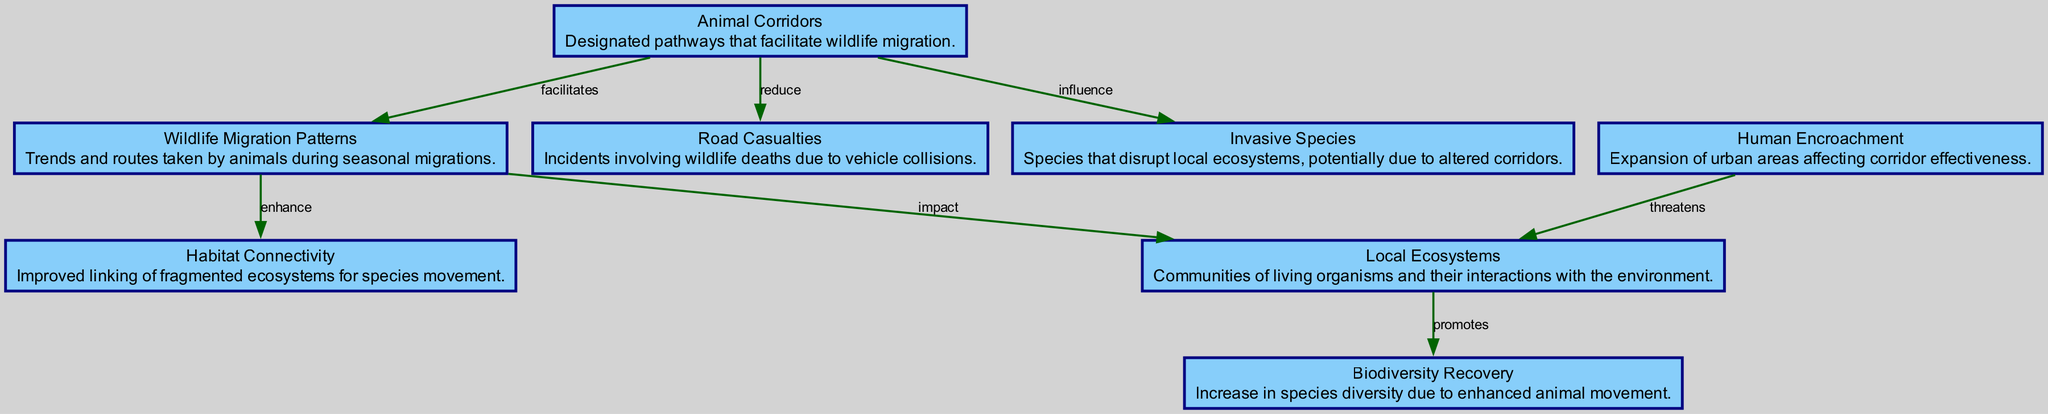What is the total number of nodes in this diagram? The diagram includes each individual entity as a node, which are: Animal Corridors, Wildlife Migration Patterns, Local Ecosystems, Biodiversity Recovery, Road Casualties, Habitat Connectivity, Invasive Species, and Human Encroachment. Counting them gives a total of 8 nodes.
Answer: 8 How many edges are present in the diagram? Each directed connection between nodes is counted as an edge. The edges are as follows: Animal Corridors to Wildlife Migration Patterns, Wildlife Migration Patterns to Local Ecosystems, Local Ecosystems to Biodiversity Recovery, Animal Corridors to Road Casualties, Wildlife Migration Patterns to Habitat Connectivity, Animal Corridors to Invasive Species, and Human Encroachment to Local Ecosystems. Counting these connections yields 7 edges.
Answer: 7 What is the label of the edge connecting Animal Corridors and Wildlife Migration Patterns? The edge that connects Animal Corridors to Wildlife Migration Patterns is labeled "facilitates." This label indicates the nature of the relationship between these two entities.
Answer: facilitates Which node promotes Biodiversity Recovery? The node that promotes Biodiversity Recovery is Local Ecosystems. This indicates that the health or attributes of Local Ecosystems are directly linked to the increase in Biodiversity Recovery.
Answer: Local Ecosystems What impact do Wildlife Migration Patterns have on Local Ecosystems? The relationship between Wildlife Migration Patterns and Local Ecosystems is described by the edge labeled "impact." This shows that Wildlife Migration Patterns directly influence or affect Local Ecosystems.
Answer: impact How does Human Encroachment relate to Local Ecosystems? Human Encroachment is shown to threaten Local Ecosystems, which implies that the expansion of urban areas negatively affects the health and functionality of these ecosystems.
Answer: threatens How do Animal Corridors influence the presence of Invasive Species? The edge labeled "influence" indicates that Animal Corridors have a significant effect on the occurrence and impact of Invasive Species in the environment. This relationship could mean that corridors may either help spread invasive species or mitigate their effects.
Answer: influence Which node is associated with reducing Road Casualties? The edge from Animal Corridors indicates that they play a role in reducing the number of Road Casualties. This reveals that the implementation of these corridors contributes to safer wildlife movement across roadways.
Answer: Animal Corridors 